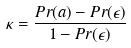Convert formula to latex. <formula><loc_0><loc_0><loc_500><loc_500>\kappa = \frac { P r ( a ) - P r ( \epsilon ) } { 1 - P r ( \epsilon ) }</formula> 